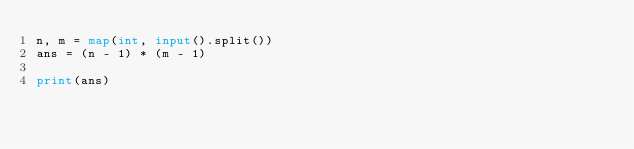Convert code to text. <code><loc_0><loc_0><loc_500><loc_500><_Python_>n, m = map(int, input().split())
ans = (n - 1) * (m - 1)

print(ans)</code> 